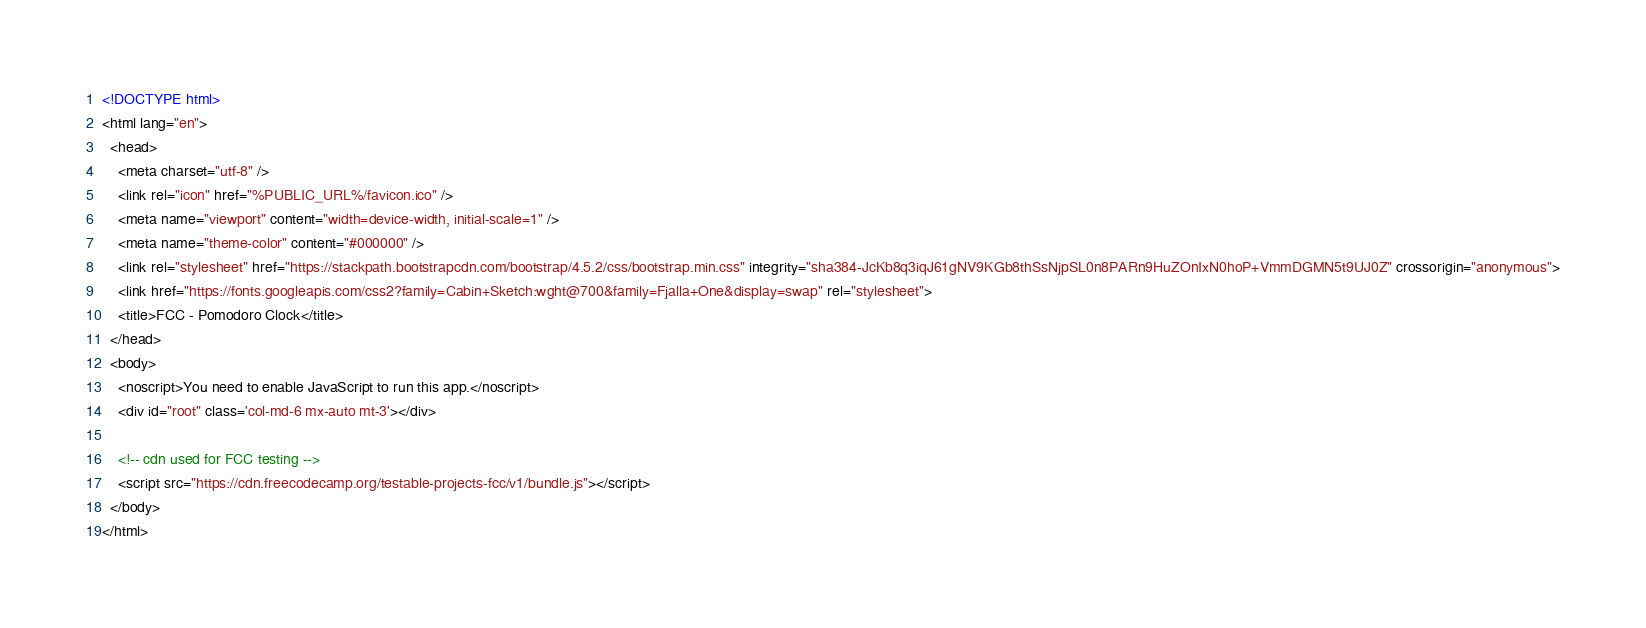Convert code to text. <code><loc_0><loc_0><loc_500><loc_500><_HTML_><!DOCTYPE html>
<html lang="en">
  <head>
    <meta charset="utf-8" />
    <link rel="icon" href="%PUBLIC_URL%/favicon.ico" />
    <meta name="viewport" content="width=device-width, initial-scale=1" />
    <meta name="theme-color" content="#000000" />
    <link rel="stylesheet" href="https://stackpath.bootstrapcdn.com/bootstrap/4.5.2/css/bootstrap.min.css" integrity="sha384-JcKb8q3iqJ61gNV9KGb8thSsNjpSL0n8PARn9HuZOnIxN0hoP+VmmDGMN5t9UJ0Z" crossorigin="anonymous">
    <link href="https://fonts.googleapis.com/css2?family=Cabin+Sketch:wght@700&family=Fjalla+One&display=swap" rel="stylesheet"> 
    <title>FCC - Pomodoro Clock</title>
  </head>
  <body>
    <noscript>You need to enable JavaScript to run this app.</noscript>
    <div id="root" class='col-md-6 mx-auto mt-3'></div>
  
    <!-- cdn used for FCC testing -->
    <script src="https://cdn.freecodecamp.org/testable-projects-fcc/v1/bundle.js"></script>
  </body>
</html>
</code> 